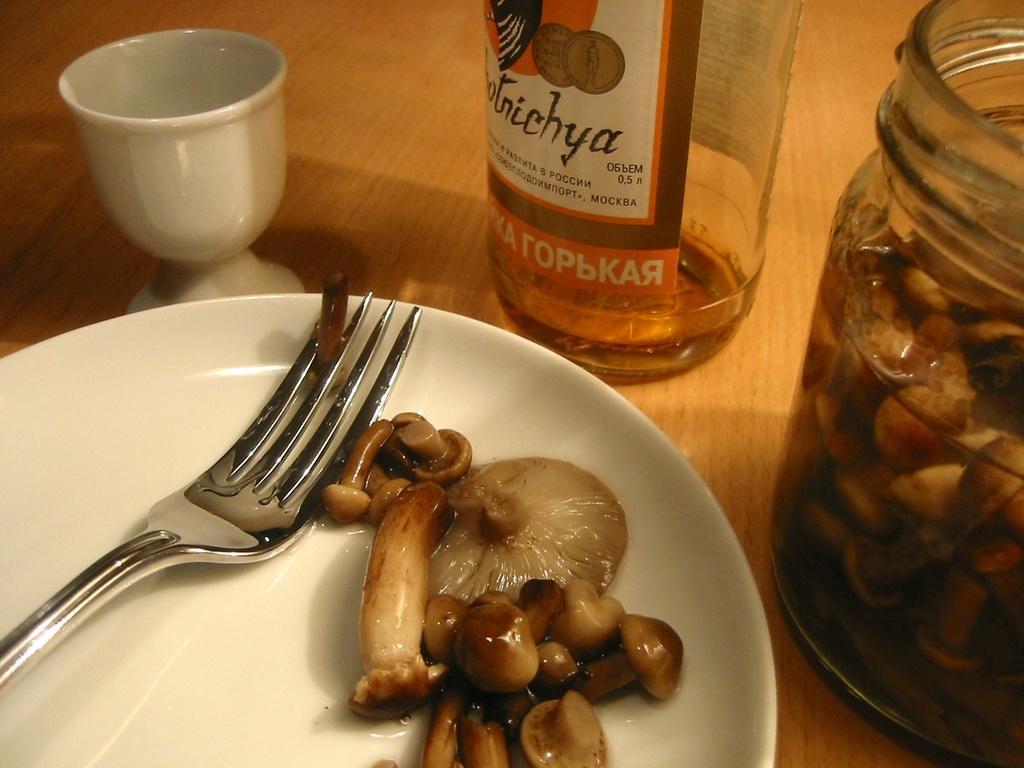Can you describe this image briefly? In this image there is a table with a cup, a bottle, a jar with with mushrooms and sauce, and a plate with a fork and mushrooms on it. 